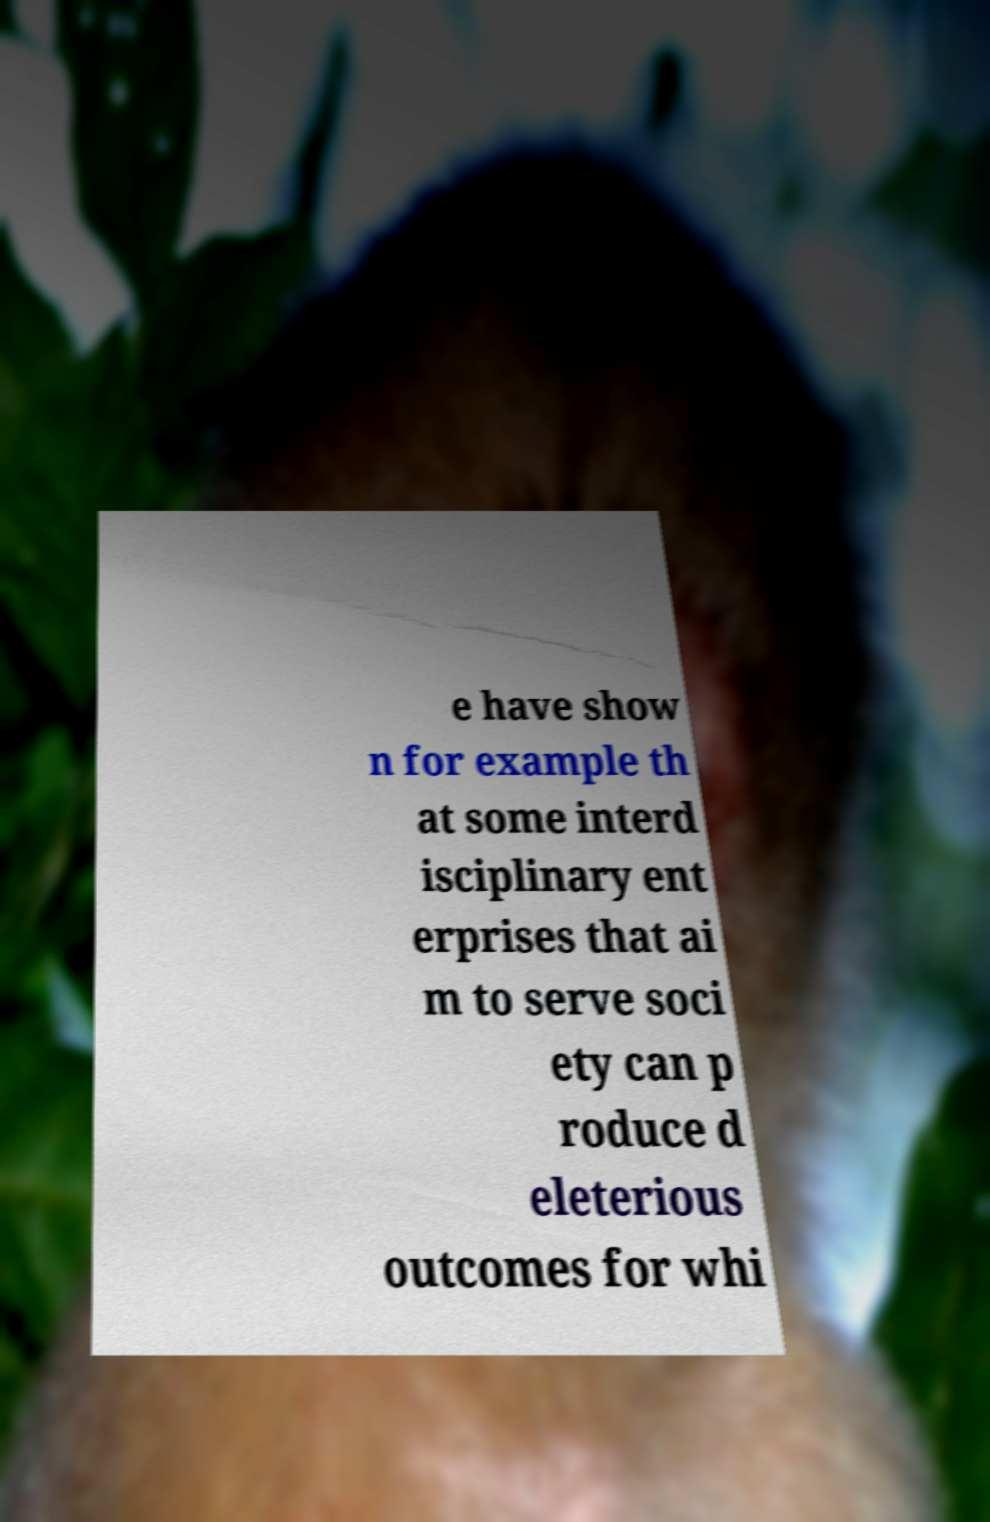There's text embedded in this image that I need extracted. Can you transcribe it verbatim? e have show n for example th at some interd isciplinary ent erprises that ai m to serve soci ety can p roduce d eleterious outcomes for whi 